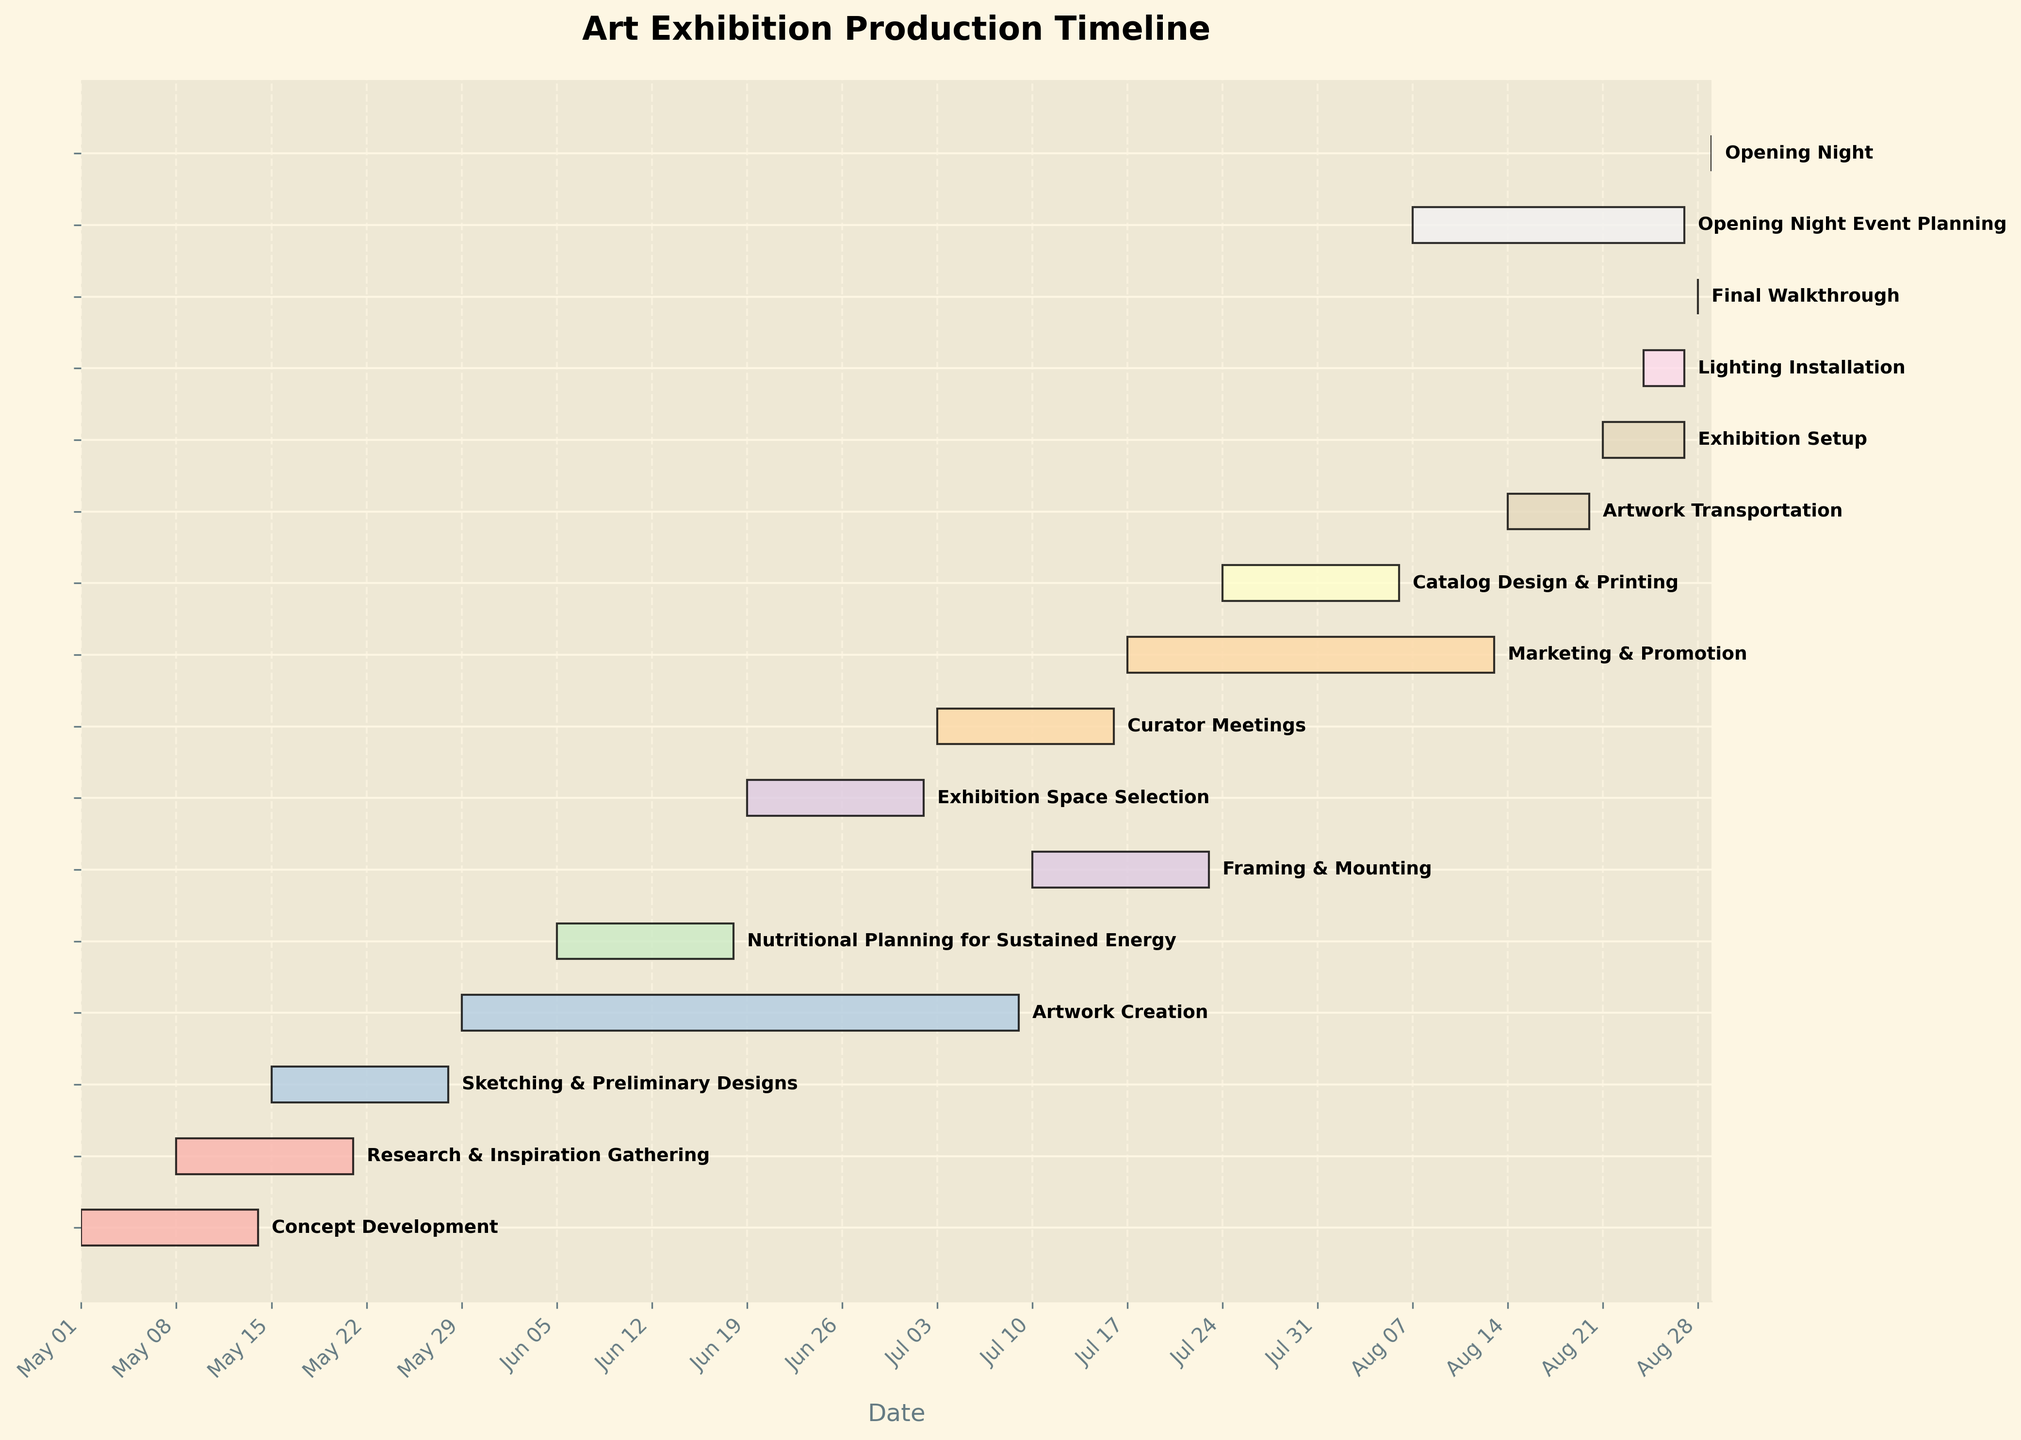What's the title of the Gantt chart? The title of a Gantt chart is usually found at the top of the figure. Look for a large, bold text that summarizes the content. In this case, it's "Art Exhibition Production Timeline".
Answer: Art Exhibition Production Timeline During which date range does the "Exhibition Setup" task occur? Look for the "Exhibition Setup" task on the Y-axis and check the corresponding horizontal bars’ start and end points. In this case, the range spans from "2023-08-21" to "2023-08-27".
Answer: 2023-08-21 to 2023-08-27 Which task has the longest duration? Calculate the duration of each task by measuring the length of the horizontal bars, which represent the number of days between the start and end dates. The longest bar is for "Artwork Creation" which spans from 2023-05-29 to 2023-07-09.
Answer: Artwork Creation How many tasks overlap with the "Research & Inspiration Gathering" task? Identify the "Research & Inspiration Gathering" task timeline and count the number of other tasks that have any part of their timeline overlapping with this task. "Concept Development" and "Sketching & Preliminary Designs" overlap with it.
Answer: 2 tasks Which tasks are scheduled to happen concurrently with "Marketing & Promotion"? Identify the time period for "Marketing & Promotion" from 2023-07-17 to 2023-08-13, then find all other tasks that overlap with this period. "Curator Meetings", "Catalog Design & Printing", "Opening Night Event Planning" overlap with it.
Answer: Curator Meetings, Catalog Design & Printing, Opening Night Event Planning Are there any tasks that start exactly on the same date? If so, which ones? Look for tasks that have identical start dates on the X-axis. "Curator Meetings" and "Catalog Design & Printing" both start on 2023-07-24.
Answer: Curator Meetings and Catalog Design & Printing Which tasks have a duration shorter than one week? Calculate the duration of each task. Tasks with a duration shorter than one week will have bars representing less than 7 days. "Final Walkthrough" and "Lighting Installation" have durations shorter than one week.
Answer: Final Walkthrough and Lighting Installation What is the total duration of the "Artwork Transportation" and "Exhibition Setup" tasks combined? Sum up the duration of both tasks. "Artwork Transportation" runs from 2023-08-14 to 2023-08-20 (7 days) and "Exhibition Setup" runs from 2023-08-21 to 2023-08-27 (7 days). Therefore, the total duration is 14 days.
Answer: 14 days When does the "Opening Night Event Planning" task start and end? Check the "Opening Night Event Planning" task on the Y-axis and identify its corresponding start and end dates. It starts on 2023-08-07 and ends on 2023-08-27.
Answer: 2023-08-07 to 2023-08-27 